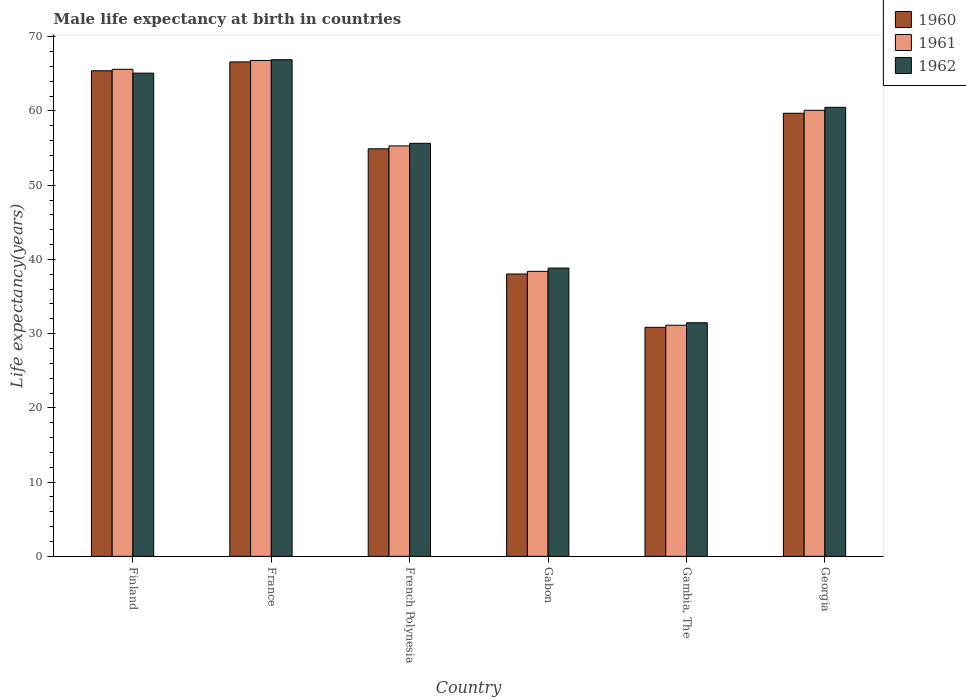What is the label of the 4th group of bars from the left?
Give a very brief answer. Gabon. In how many cases, is the number of bars for a given country not equal to the number of legend labels?
Provide a short and direct response. 0. What is the male life expectancy at birth in 1961 in French Polynesia?
Keep it short and to the point. 55.29. Across all countries, what is the maximum male life expectancy at birth in 1961?
Ensure brevity in your answer.  66.8. Across all countries, what is the minimum male life expectancy at birth in 1960?
Ensure brevity in your answer.  30.85. In which country was the male life expectancy at birth in 1962 maximum?
Offer a terse response. France. In which country was the male life expectancy at birth in 1962 minimum?
Provide a succinct answer. Gambia, The. What is the total male life expectancy at birth in 1961 in the graph?
Provide a succinct answer. 317.31. What is the difference between the male life expectancy at birth in 1962 in Finland and that in French Polynesia?
Ensure brevity in your answer.  9.45. What is the difference between the male life expectancy at birth in 1962 in France and the male life expectancy at birth in 1960 in Gabon?
Keep it short and to the point. 28.87. What is the average male life expectancy at birth in 1960 per country?
Give a very brief answer. 52.58. What is the difference between the male life expectancy at birth of/in 1962 and male life expectancy at birth of/in 1960 in French Polynesia?
Provide a succinct answer. 0.74. In how many countries, is the male life expectancy at birth in 1962 greater than 18 years?
Give a very brief answer. 6. What is the ratio of the male life expectancy at birth in 1960 in Gambia, The to that in Georgia?
Ensure brevity in your answer.  0.52. Is the male life expectancy at birth in 1960 in Gambia, The less than that in Georgia?
Make the answer very short. Yes. What is the difference between the highest and the second highest male life expectancy at birth in 1962?
Provide a succinct answer. -1.81. What is the difference between the highest and the lowest male life expectancy at birth in 1961?
Provide a succinct answer. 35.67. Is it the case that in every country, the sum of the male life expectancy at birth in 1961 and male life expectancy at birth in 1960 is greater than the male life expectancy at birth in 1962?
Keep it short and to the point. Yes. How many bars are there?
Your answer should be compact. 18. What is the difference between two consecutive major ticks on the Y-axis?
Ensure brevity in your answer.  10. Does the graph contain any zero values?
Provide a succinct answer. No. Where does the legend appear in the graph?
Your response must be concise. Top right. How many legend labels are there?
Keep it short and to the point. 3. What is the title of the graph?
Your answer should be very brief. Male life expectancy at birth in countries. What is the label or title of the X-axis?
Make the answer very short. Country. What is the label or title of the Y-axis?
Give a very brief answer. Life expectancy(years). What is the Life expectancy(years) of 1960 in Finland?
Provide a succinct answer. 65.41. What is the Life expectancy(years) in 1961 in Finland?
Offer a very short reply. 65.61. What is the Life expectancy(years) of 1962 in Finland?
Your answer should be very brief. 65.09. What is the Life expectancy(years) in 1960 in France?
Provide a succinct answer. 66.6. What is the Life expectancy(years) in 1961 in France?
Keep it short and to the point. 66.8. What is the Life expectancy(years) of 1962 in France?
Provide a succinct answer. 66.9. What is the Life expectancy(years) of 1960 in French Polynesia?
Offer a very short reply. 54.9. What is the Life expectancy(years) in 1961 in French Polynesia?
Your answer should be very brief. 55.29. What is the Life expectancy(years) of 1962 in French Polynesia?
Give a very brief answer. 55.64. What is the Life expectancy(years) in 1960 in Gabon?
Offer a very short reply. 38.03. What is the Life expectancy(years) in 1961 in Gabon?
Provide a succinct answer. 38.39. What is the Life expectancy(years) of 1962 in Gabon?
Your answer should be very brief. 38.83. What is the Life expectancy(years) of 1960 in Gambia, The?
Your answer should be very brief. 30.85. What is the Life expectancy(years) in 1961 in Gambia, The?
Ensure brevity in your answer.  31.13. What is the Life expectancy(years) in 1962 in Gambia, The?
Your answer should be very brief. 31.46. What is the Life expectancy(years) in 1960 in Georgia?
Your answer should be very brief. 59.69. What is the Life expectancy(years) of 1961 in Georgia?
Your response must be concise. 60.09. What is the Life expectancy(years) in 1962 in Georgia?
Provide a succinct answer. 60.49. Across all countries, what is the maximum Life expectancy(years) in 1960?
Offer a very short reply. 66.6. Across all countries, what is the maximum Life expectancy(years) in 1961?
Your response must be concise. 66.8. Across all countries, what is the maximum Life expectancy(years) of 1962?
Offer a terse response. 66.9. Across all countries, what is the minimum Life expectancy(years) of 1960?
Offer a very short reply. 30.85. Across all countries, what is the minimum Life expectancy(years) in 1961?
Provide a succinct answer. 31.13. Across all countries, what is the minimum Life expectancy(years) in 1962?
Your response must be concise. 31.46. What is the total Life expectancy(years) of 1960 in the graph?
Your answer should be compact. 315.48. What is the total Life expectancy(years) of 1961 in the graph?
Provide a short and direct response. 317.31. What is the total Life expectancy(years) in 1962 in the graph?
Ensure brevity in your answer.  318.41. What is the difference between the Life expectancy(years) of 1960 in Finland and that in France?
Make the answer very short. -1.19. What is the difference between the Life expectancy(years) in 1961 in Finland and that in France?
Make the answer very short. -1.19. What is the difference between the Life expectancy(years) of 1962 in Finland and that in France?
Give a very brief answer. -1.81. What is the difference between the Life expectancy(years) in 1960 in Finland and that in French Polynesia?
Make the answer very short. 10.51. What is the difference between the Life expectancy(years) in 1961 in Finland and that in French Polynesia?
Your response must be concise. 10.32. What is the difference between the Life expectancy(years) of 1962 in Finland and that in French Polynesia?
Give a very brief answer. 9.45. What is the difference between the Life expectancy(years) in 1960 in Finland and that in Gabon?
Offer a very short reply. 27.38. What is the difference between the Life expectancy(years) of 1961 in Finland and that in Gabon?
Offer a very short reply. 27.22. What is the difference between the Life expectancy(years) in 1962 in Finland and that in Gabon?
Your answer should be compact. 26.26. What is the difference between the Life expectancy(years) in 1960 in Finland and that in Gambia, The?
Offer a very short reply. 34.56. What is the difference between the Life expectancy(years) in 1961 in Finland and that in Gambia, The?
Keep it short and to the point. 34.48. What is the difference between the Life expectancy(years) in 1962 in Finland and that in Gambia, The?
Ensure brevity in your answer.  33.62. What is the difference between the Life expectancy(years) of 1960 in Finland and that in Georgia?
Your response must be concise. 5.72. What is the difference between the Life expectancy(years) of 1961 in Finland and that in Georgia?
Offer a very short reply. 5.52. What is the difference between the Life expectancy(years) of 1962 in Finland and that in Georgia?
Offer a very short reply. 4.6. What is the difference between the Life expectancy(years) of 1960 in France and that in French Polynesia?
Offer a very short reply. 11.7. What is the difference between the Life expectancy(years) of 1961 in France and that in French Polynesia?
Your answer should be very brief. 11.51. What is the difference between the Life expectancy(years) in 1962 in France and that in French Polynesia?
Your answer should be very brief. 11.26. What is the difference between the Life expectancy(years) of 1960 in France and that in Gabon?
Ensure brevity in your answer.  28.57. What is the difference between the Life expectancy(years) of 1961 in France and that in Gabon?
Offer a terse response. 28.41. What is the difference between the Life expectancy(years) of 1962 in France and that in Gabon?
Offer a very short reply. 28.07. What is the difference between the Life expectancy(years) of 1960 in France and that in Gambia, The?
Keep it short and to the point. 35.75. What is the difference between the Life expectancy(years) of 1961 in France and that in Gambia, The?
Give a very brief answer. 35.67. What is the difference between the Life expectancy(years) of 1962 in France and that in Gambia, The?
Your response must be concise. 35.44. What is the difference between the Life expectancy(years) of 1960 in France and that in Georgia?
Provide a succinct answer. 6.91. What is the difference between the Life expectancy(years) of 1961 in France and that in Georgia?
Make the answer very short. 6.71. What is the difference between the Life expectancy(years) of 1962 in France and that in Georgia?
Offer a very short reply. 6.41. What is the difference between the Life expectancy(years) of 1960 in French Polynesia and that in Gabon?
Offer a terse response. 16.86. What is the difference between the Life expectancy(years) in 1962 in French Polynesia and that in Gabon?
Give a very brief answer. 16.8. What is the difference between the Life expectancy(years) of 1960 in French Polynesia and that in Gambia, The?
Give a very brief answer. 24.05. What is the difference between the Life expectancy(years) of 1961 in French Polynesia and that in Gambia, The?
Your response must be concise. 24.16. What is the difference between the Life expectancy(years) of 1962 in French Polynesia and that in Gambia, The?
Give a very brief answer. 24.17. What is the difference between the Life expectancy(years) of 1960 in French Polynesia and that in Georgia?
Provide a short and direct response. -4.79. What is the difference between the Life expectancy(years) in 1961 in French Polynesia and that in Georgia?
Offer a very short reply. -4.8. What is the difference between the Life expectancy(years) in 1962 in French Polynesia and that in Georgia?
Your response must be concise. -4.85. What is the difference between the Life expectancy(years) in 1960 in Gabon and that in Gambia, The?
Provide a short and direct response. 7.18. What is the difference between the Life expectancy(years) of 1961 in Gabon and that in Gambia, The?
Provide a succinct answer. 7.26. What is the difference between the Life expectancy(years) in 1962 in Gabon and that in Gambia, The?
Keep it short and to the point. 7.37. What is the difference between the Life expectancy(years) of 1960 in Gabon and that in Georgia?
Your response must be concise. -21.65. What is the difference between the Life expectancy(years) in 1961 in Gabon and that in Georgia?
Ensure brevity in your answer.  -21.7. What is the difference between the Life expectancy(years) of 1962 in Gabon and that in Georgia?
Make the answer very short. -21.65. What is the difference between the Life expectancy(years) in 1960 in Gambia, The and that in Georgia?
Offer a terse response. -28.84. What is the difference between the Life expectancy(years) of 1961 in Gambia, The and that in Georgia?
Make the answer very short. -28.95. What is the difference between the Life expectancy(years) of 1962 in Gambia, The and that in Georgia?
Ensure brevity in your answer.  -29.02. What is the difference between the Life expectancy(years) in 1960 in Finland and the Life expectancy(years) in 1961 in France?
Offer a terse response. -1.39. What is the difference between the Life expectancy(years) in 1960 in Finland and the Life expectancy(years) in 1962 in France?
Your answer should be very brief. -1.49. What is the difference between the Life expectancy(years) in 1961 in Finland and the Life expectancy(years) in 1962 in France?
Keep it short and to the point. -1.29. What is the difference between the Life expectancy(years) in 1960 in Finland and the Life expectancy(years) in 1961 in French Polynesia?
Offer a terse response. 10.12. What is the difference between the Life expectancy(years) in 1960 in Finland and the Life expectancy(years) in 1962 in French Polynesia?
Provide a short and direct response. 9.77. What is the difference between the Life expectancy(years) of 1961 in Finland and the Life expectancy(years) of 1962 in French Polynesia?
Make the answer very short. 9.97. What is the difference between the Life expectancy(years) in 1960 in Finland and the Life expectancy(years) in 1961 in Gabon?
Ensure brevity in your answer.  27.02. What is the difference between the Life expectancy(years) in 1960 in Finland and the Life expectancy(years) in 1962 in Gabon?
Ensure brevity in your answer.  26.58. What is the difference between the Life expectancy(years) in 1961 in Finland and the Life expectancy(years) in 1962 in Gabon?
Provide a short and direct response. 26.78. What is the difference between the Life expectancy(years) in 1960 in Finland and the Life expectancy(years) in 1961 in Gambia, The?
Give a very brief answer. 34.28. What is the difference between the Life expectancy(years) in 1960 in Finland and the Life expectancy(years) in 1962 in Gambia, The?
Offer a terse response. 33.95. What is the difference between the Life expectancy(years) in 1961 in Finland and the Life expectancy(years) in 1962 in Gambia, The?
Make the answer very short. 34.15. What is the difference between the Life expectancy(years) in 1960 in Finland and the Life expectancy(years) in 1961 in Georgia?
Ensure brevity in your answer.  5.32. What is the difference between the Life expectancy(years) of 1960 in Finland and the Life expectancy(years) of 1962 in Georgia?
Make the answer very short. 4.92. What is the difference between the Life expectancy(years) in 1961 in Finland and the Life expectancy(years) in 1962 in Georgia?
Ensure brevity in your answer.  5.12. What is the difference between the Life expectancy(years) in 1960 in France and the Life expectancy(years) in 1961 in French Polynesia?
Offer a terse response. 11.31. What is the difference between the Life expectancy(years) of 1960 in France and the Life expectancy(years) of 1962 in French Polynesia?
Your response must be concise. 10.96. What is the difference between the Life expectancy(years) of 1961 in France and the Life expectancy(years) of 1962 in French Polynesia?
Your answer should be very brief. 11.16. What is the difference between the Life expectancy(years) in 1960 in France and the Life expectancy(years) in 1961 in Gabon?
Your answer should be very brief. 28.21. What is the difference between the Life expectancy(years) in 1960 in France and the Life expectancy(years) in 1962 in Gabon?
Offer a very short reply. 27.77. What is the difference between the Life expectancy(years) in 1961 in France and the Life expectancy(years) in 1962 in Gabon?
Ensure brevity in your answer.  27.97. What is the difference between the Life expectancy(years) of 1960 in France and the Life expectancy(years) of 1961 in Gambia, The?
Give a very brief answer. 35.47. What is the difference between the Life expectancy(years) of 1960 in France and the Life expectancy(years) of 1962 in Gambia, The?
Keep it short and to the point. 35.13. What is the difference between the Life expectancy(years) of 1961 in France and the Life expectancy(years) of 1962 in Gambia, The?
Ensure brevity in your answer.  35.34. What is the difference between the Life expectancy(years) of 1960 in France and the Life expectancy(years) of 1961 in Georgia?
Keep it short and to the point. 6.51. What is the difference between the Life expectancy(years) in 1960 in France and the Life expectancy(years) in 1962 in Georgia?
Offer a very short reply. 6.11. What is the difference between the Life expectancy(years) in 1961 in France and the Life expectancy(years) in 1962 in Georgia?
Provide a short and direct response. 6.31. What is the difference between the Life expectancy(years) of 1960 in French Polynesia and the Life expectancy(years) of 1961 in Gabon?
Give a very brief answer. 16.51. What is the difference between the Life expectancy(years) of 1960 in French Polynesia and the Life expectancy(years) of 1962 in Gabon?
Provide a short and direct response. 16.07. What is the difference between the Life expectancy(years) of 1961 in French Polynesia and the Life expectancy(years) of 1962 in Gabon?
Offer a terse response. 16.46. What is the difference between the Life expectancy(years) of 1960 in French Polynesia and the Life expectancy(years) of 1961 in Gambia, The?
Provide a short and direct response. 23.77. What is the difference between the Life expectancy(years) of 1960 in French Polynesia and the Life expectancy(years) of 1962 in Gambia, The?
Make the answer very short. 23.43. What is the difference between the Life expectancy(years) in 1961 in French Polynesia and the Life expectancy(years) in 1962 in Gambia, The?
Make the answer very short. 23.82. What is the difference between the Life expectancy(years) of 1960 in French Polynesia and the Life expectancy(years) of 1961 in Georgia?
Your answer should be compact. -5.19. What is the difference between the Life expectancy(years) in 1960 in French Polynesia and the Life expectancy(years) in 1962 in Georgia?
Your response must be concise. -5.59. What is the difference between the Life expectancy(years) of 1961 in French Polynesia and the Life expectancy(years) of 1962 in Georgia?
Provide a succinct answer. -5.2. What is the difference between the Life expectancy(years) in 1960 in Gabon and the Life expectancy(years) in 1961 in Gambia, The?
Give a very brief answer. 6.9. What is the difference between the Life expectancy(years) in 1960 in Gabon and the Life expectancy(years) in 1962 in Gambia, The?
Your answer should be compact. 6.57. What is the difference between the Life expectancy(years) of 1961 in Gabon and the Life expectancy(years) of 1962 in Gambia, The?
Keep it short and to the point. 6.92. What is the difference between the Life expectancy(years) in 1960 in Gabon and the Life expectancy(years) in 1961 in Georgia?
Provide a succinct answer. -22.05. What is the difference between the Life expectancy(years) of 1960 in Gabon and the Life expectancy(years) of 1962 in Georgia?
Ensure brevity in your answer.  -22.45. What is the difference between the Life expectancy(years) in 1961 in Gabon and the Life expectancy(years) in 1962 in Georgia?
Your answer should be compact. -22.1. What is the difference between the Life expectancy(years) in 1960 in Gambia, The and the Life expectancy(years) in 1961 in Georgia?
Offer a very short reply. -29.23. What is the difference between the Life expectancy(years) of 1960 in Gambia, The and the Life expectancy(years) of 1962 in Georgia?
Your answer should be compact. -29.64. What is the difference between the Life expectancy(years) of 1961 in Gambia, The and the Life expectancy(years) of 1962 in Georgia?
Make the answer very short. -29.36. What is the average Life expectancy(years) of 1960 per country?
Make the answer very short. 52.58. What is the average Life expectancy(years) in 1961 per country?
Offer a terse response. 52.88. What is the average Life expectancy(years) in 1962 per country?
Give a very brief answer. 53.07. What is the difference between the Life expectancy(years) of 1960 and Life expectancy(years) of 1962 in Finland?
Your response must be concise. 0.32. What is the difference between the Life expectancy(years) of 1961 and Life expectancy(years) of 1962 in Finland?
Give a very brief answer. 0.52. What is the difference between the Life expectancy(years) in 1960 and Life expectancy(years) in 1961 in French Polynesia?
Your answer should be very brief. -0.39. What is the difference between the Life expectancy(years) of 1960 and Life expectancy(years) of 1962 in French Polynesia?
Your answer should be very brief. -0.74. What is the difference between the Life expectancy(years) in 1961 and Life expectancy(years) in 1962 in French Polynesia?
Ensure brevity in your answer.  -0.35. What is the difference between the Life expectancy(years) in 1960 and Life expectancy(years) in 1961 in Gabon?
Ensure brevity in your answer.  -0.35. What is the difference between the Life expectancy(years) of 1960 and Life expectancy(years) of 1962 in Gabon?
Offer a terse response. -0.8. What is the difference between the Life expectancy(years) of 1961 and Life expectancy(years) of 1962 in Gabon?
Make the answer very short. -0.44. What is the difference between the Life expectancy(years) of 1960 and Life expectancy(years) of 1961 in Gambia, The?
Offer a very short reply. -0.28. What is the difference between the Life expectancy(years) in 1960 and Life expectancy(years) in 1962 in Gambia, The?
Offer a terse response. -0.61. What is the difference between the Life expectancy(years) in 1961 and Life expectancy(years) in 1962 in Gambia, The?
Your answer should be very brief. -0.33. What is the difference between the Life expectancy(years) of 1960 and Life expectancy(years) of 1961 in Georgia?
Keep it short and to the point. -0.4. What is the difference between the Life expectancy(years) in 1960 and Life expectancy(years) in 1962 in Georgia?
Give a very brief answer. -0.8. What is the difference between the Life expectancy(years) of 1961 and Life expectancy(years) of 1962 in Georgia?
Your answer should be very brief. -0.4. What is the ratio of the Life expectancy(years) in 1960 in Finland to that in France?
Your answer should be very brief. 0.98. What is the ratio of the Life expectancy(years) of 1961 in Finland to that in France?
Ensure brevity in your answer.  0.98. What is the ratio of the Life expectancy(years) of 1962 in Finland to that in France?
Your answer should be compact. 0.97. What is the ratio of the Life expectancy(years) in 1960 in Finland to that in French Polynesia?
Offer a very short reply. 1.19. What is the ratio of the Life expectancy(years) of 1961 in Finland to that in French Polynesia?
Provide a short and direct response. 1.19. What is the ratio of the Life expectancy(years) in 1962 in Finland to that in French Polynesia?
Offer a terse response. 1.17. What is the ratio of the Life expectancy(years) of 1960 in Finland to that in Gabon?
Provide a short and direct response. 1.72. What is the ratio of the Life expectancy(years) in 1961 in Finland to that in Gabon?
Keep it short and to the point. 1.71. What is the ratio of the Life expectancy(years) of 1962 in Finland to that in Gabon?
Your answer should be very brief. 1.68. What is the ratio of the Life expectancy(years) of 1960 in Finland to that in Gambia, The?
Offer a very short reply. 2.12. What is the ratio of the Life expectancy(years) in 1961 in Finland to that in Gambia, The?
Your answer should be compact. 2.11. What is the ratio of the Life expectancy(years) of 1962 in Finland to that in Gambia, The?
Your answer should be compact. 2.07. What is the ratio of the Life expectancy(years) of 1960 in Finland to that in Georgia?
Your response must be concise. 1.1. What is the ratio of the Life expectancy(years) of 1961 in Finland to that in Georgia?
Offer a terse response. 1.09. What is the ratio of the Life expectancy(years) in 1962 in Finland to that in Georgia?
Your answer should be compact. 1.08. What is the ratio of the Life expectancy(years) in 1960 in France to that in French Polynesia?
Make the answer very short. 1.21. What is the ratio of the Life expectancy(years) in 1961 in France to that in French Polynesia?
Your answer should be compact. 1.21. What is the ratio of the Life expectancy(years) in 1962 in France to that in French Polynesia?
Provide a short and direct response. 1.2. What is the ratio of the Life expectancy(years) of 1960 in France to that in Gabon?
Your response must be concise. 1.75. What is the ratio of the Life expectancy(years) in 1961 in France to that in Gabon?
Provide a short and direct response. 1.74. What is the ratio of the Life expectancy(years) in 1962 in France to that in Gabon?
Ensure brevity in your answer.  1.72. What is the ratio of the Life expectancy(years) of 1960 in France to that in Gambia, The?
Give a very brief answer. 2.16. What is the ratio of the Life expectancy(years) in 1961 in France to that in Gambia, The?
Your response must be concise. 2.15. What is the ratio of the Life expectancy(years) in 1962 in France to that in Gambia, The?
Your answer should be very brief. 2.13. What is the ratio of the Life expectancy(years) of 1960 in France to that in Georgia?
Ensure brevity in your answer.  1.12. What is the ratio of the Life expectancy(years) in 1961 in France to that in Georgia?
Provide a succinct answer. 1.11. What is the ratio of the Life expectancy(years) in 1962 in France to that in Georgia?
Your answer should be very brief. 1.11. What is the ratio of the Life expectancy(years) of 1960 in French Polynesia to that in Gabon?
Provide a short and direct response. 1.44. What is the ratio of the Life expectancy(years) of 1961 in French Polynesia to that in Gabon?
Offer a terse response. 1.44. What is the ratio of the Life expectancy(years) of 1962 in French Polynesia to that in Gabon?
Offer a very short reply. 1.43. What is the ratio of the Life expectancy(years) in 1960 in French Polynesia to that in Gambia, The?
Your answer should be compact. 1.78. What is the ratio of the Life expectancy(years) in 1961 in French Polynesia to that in Gambia, The?
Provide a short and direct response. 1.78. What is the ratio of the Life expectancy(years) in 1962 in French Polynesia to that in Gambia, The?
Your response must be concise. 1.77. What is the ratio of the Life expectancy(years) in 1960 in French Polynesia to that in Georgia?
Provide a short and direct response. 0.92. What is the ratio of the Life expectancy(years) in 1961 in French Polynesia to that in Georgia?
Offer a very short reply. 0.92. What is the ratio of the Life expectancy(years) of 1962 in French Polynesia to that in Georgia?
Provide a short and direct response. 0.92. What is the ratio of the Life expectancy(years) of 1960 in Gabon to that in Gambia, The?
Provide a short and direct response. 1.23. What is the ratio of the Life expectancy(years) of 1961 in Gabon to that in Gambia, The?
Offer a terse response. 1.23. What is the ratio of the Life expectancy(years) in 1962 in Gabon to that in Gambia, The?
Ensure brevity in your answer.  1.23. What is the ratio of the Life expectancy(years) in 1960 in Gabon to that in Georgia?
Your answer should be compact. 0.64. What is the ratio of the Life expectancy(years) of 1961 in Gabon to that in Georgia?
Give a very brief answer. 0.64. What is the ratio of the Life expectancy(years) in 1962 in Gabon to that in Georgia?
Your response must be concise. 0.64. What is the ratio of the Life expectancy(years) of 1960 in Gambia, The to that in Georgia?
Give a very brief answer. 0.52. What is the ratio of the Life expectancy(years) of 1961 in Gambia, The to that in Georgia?
Provide a short and direct response. 0.52. What is the ratio of the Life expectancy(years) of 1962 in Gambia, The to that in Georgia?
Your response must be concise. 0.52. What is the difference between the highest and the second highest Life expectancy(years) in 1960?
Your response must be concise. 1.19. What is the difference between the highest and the second highest Life expectancy(years) of 1961?
Ensure brevity in your answer.  1.19. What is the difference between the highest and the second highest Life expectancy(years) of 1962?
Keep it short and to the point. 1.81. What is the difference between the highest and the lowest Life expectancy(years) of 1960?
Offer a terse response. 35.75. What is the difference between the highest and the lowest Life expectancy(years) in 1961?
Your answer should be compact. 35.67. What is the difference between the highest and the lowest Life expectancy(years) of 1962?
Your answer should be very brief. 35.44. 